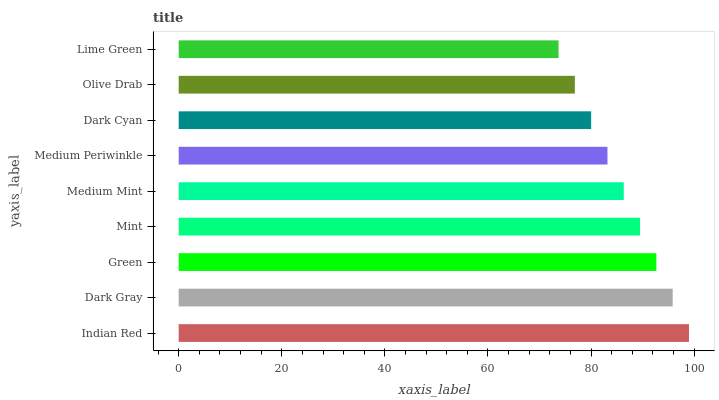Is Lime Green the minimum?
Answer yes or no. Yes. Is Indian Red the maximum?
Answer yes or no. Yes. Is Dark Gray the minimum?
Answer yes or no. No. Is Dark Gray the maximum?
Answer yes or no. No. Is Indian Red greater than Dark Gray?
Answer yes or no. Yes. Is Dark Gray less than Indian Red?
Answer yes or no. Yes. Is Dark Gray greater than Indian Red?
Answer yes or no. No. Is Indian Red less than Dark Gray?
Answer yes or no. No. Is Medium Mint the high median?
Answer yes or no. Yes. Is Medium Mint the low median?
Answer yes or no. Yes. Is Mint the high median?
Answer yes or no. No. Is Olive Drab the low median?
Answer yes or no. No. 